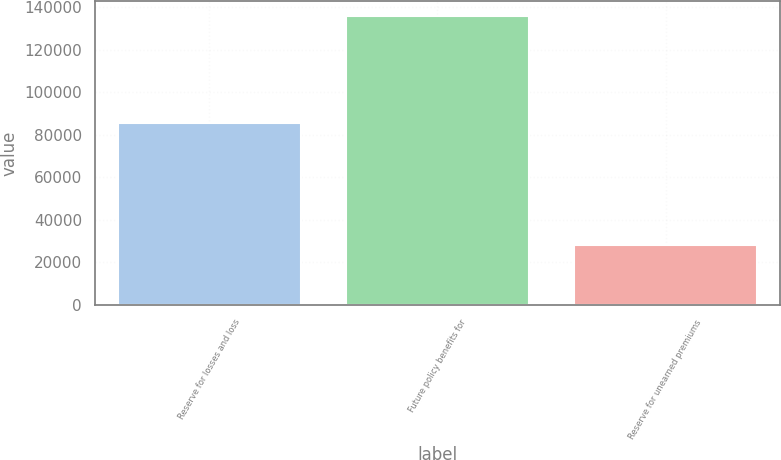<chart> <loc_0><loc_0><loc_500><loc_500><bar_chart><fcel>Reserve for losses and loss<fcel>Future policy benefits for<fcel>Reserve for unearned premiums<nl><fcel>85500<fcel>136068<fcel>28022<nl></chart> 